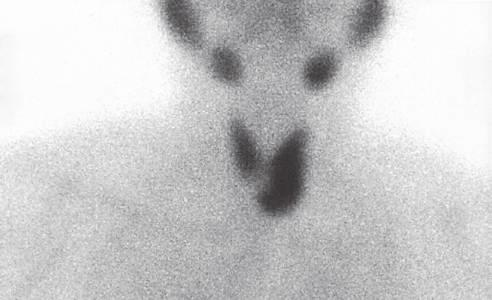does rugal demonstrate an area of increased uptake corresponding to the left inferior parathyroid gland arrow?
Answer the question using a single word or phrase. No 